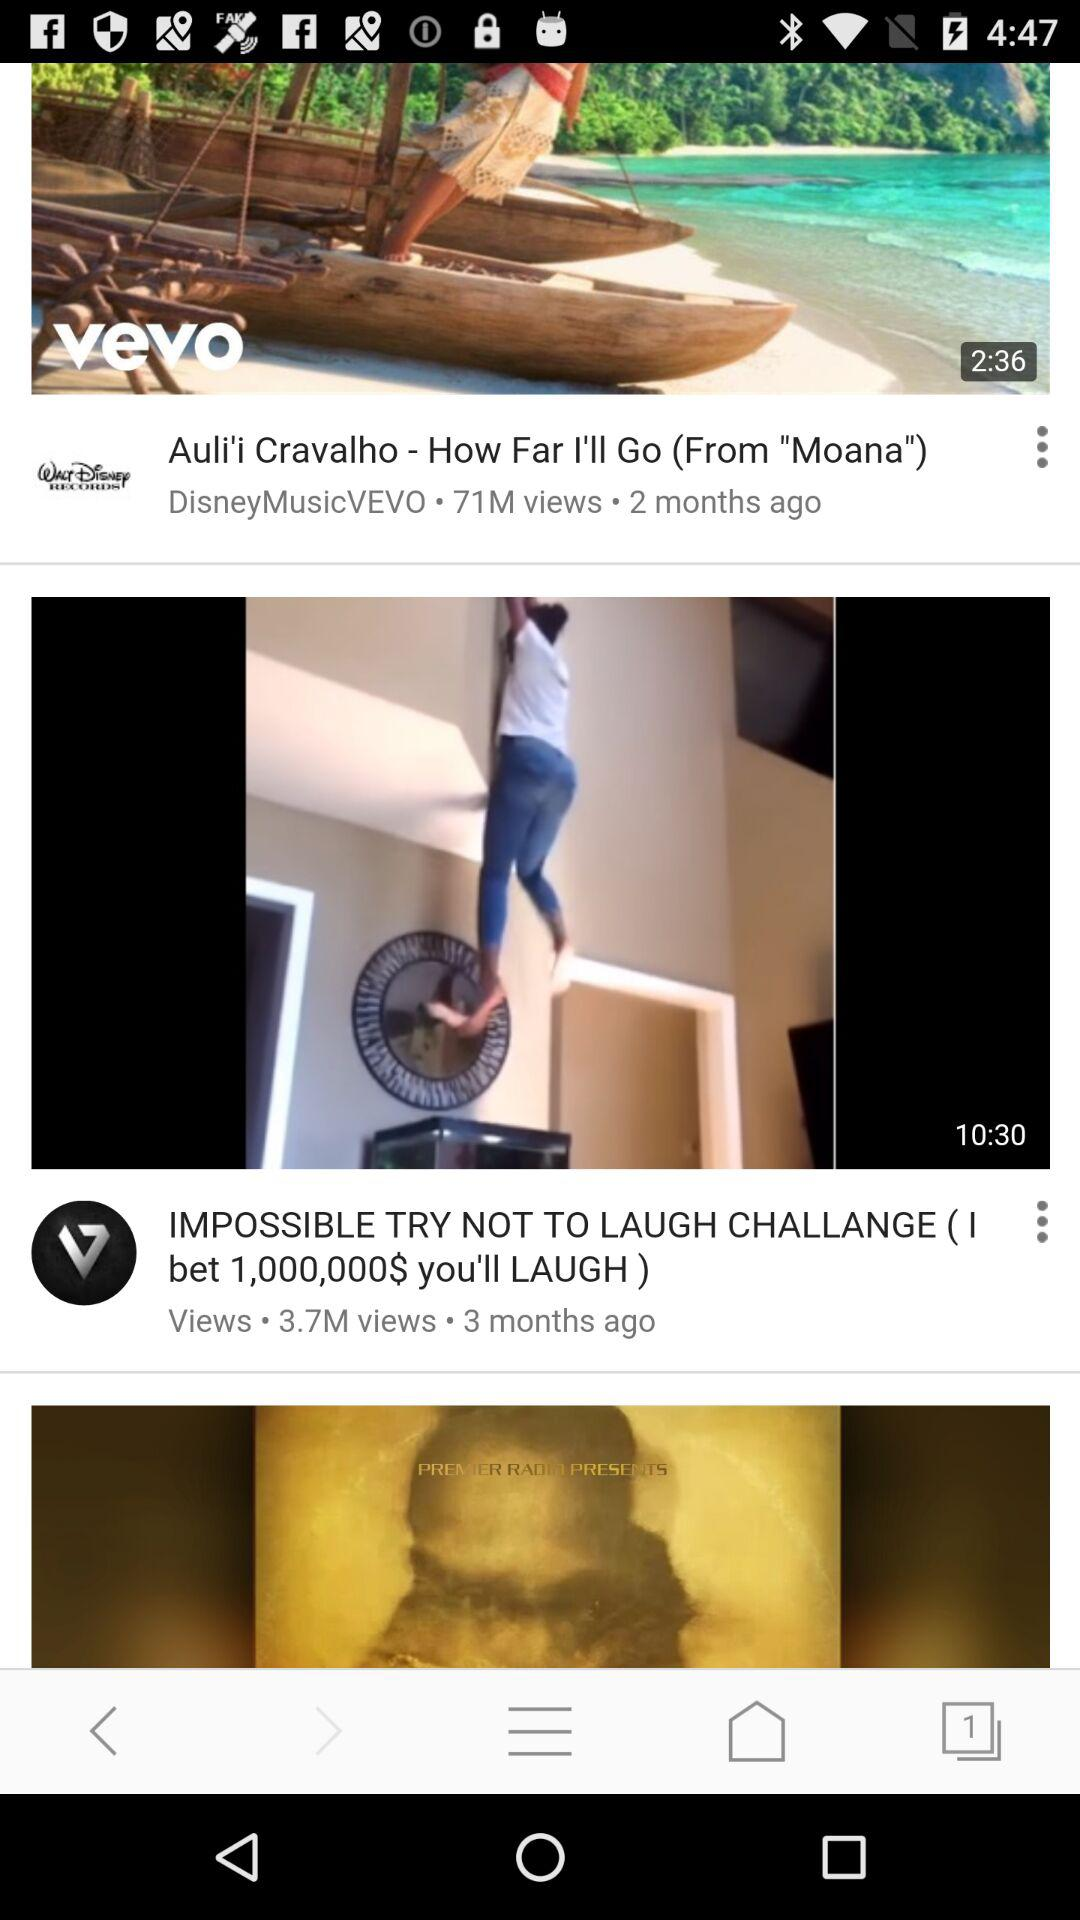How many views are there on the "IMPOSSIBLE TRY NOT TO LAUGH CHALLANGE (I bet 1,000,000$ you'll LAUGH)" video? There are 3.7 million views on the "IMPOSSIBLE TRY NOT TO LAUGH CHALLANGE (I bet 1,000,000$ you'll LAUGH)" video. 